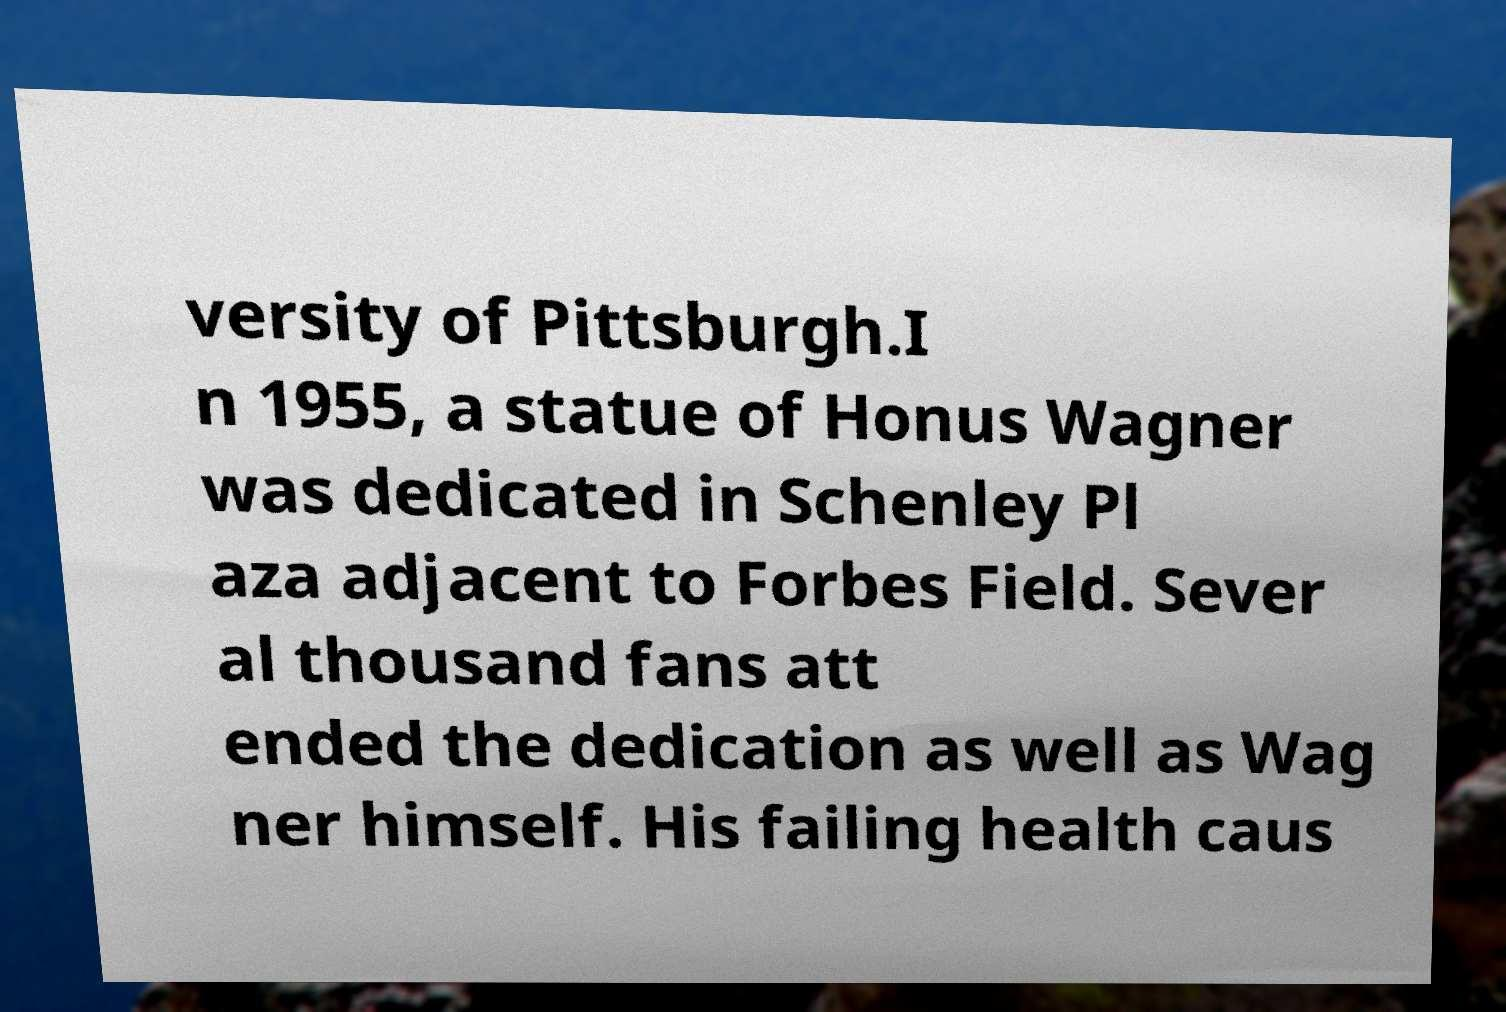Can you accurately transcribe the text from the provided image for me? versity of Pittsburgh.I n 1955, a statue of Honus Wagner was dedicated in Schenley Pl aza adjacent to Forbes Field. Sever al thousand fans att ended the dedication as well as Wag ner himself. His failing health caus 